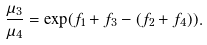Convert formula to latex. <formula><loc_0><loc_0><loc_500><loc_500>\frac { \mu _ { 3 } } { \mu _ { 4 } } = \exp ( f _ { 1 } + f _ { 3 } - ( f _ { 2 } + f _ { 4 } ) ) .</formula> 